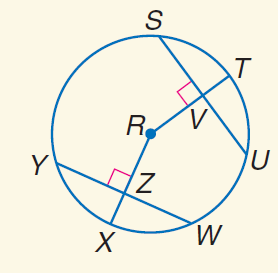Answer the mathemtical geometry problem and directly provide the correct option letter.
Question: In \odot R, S U = 20, Y W = 20, and m \widehat Y X = 45. Find m \widehat Y W.
Choices: A: 20 B: 30 C: 45 D: 90 D 